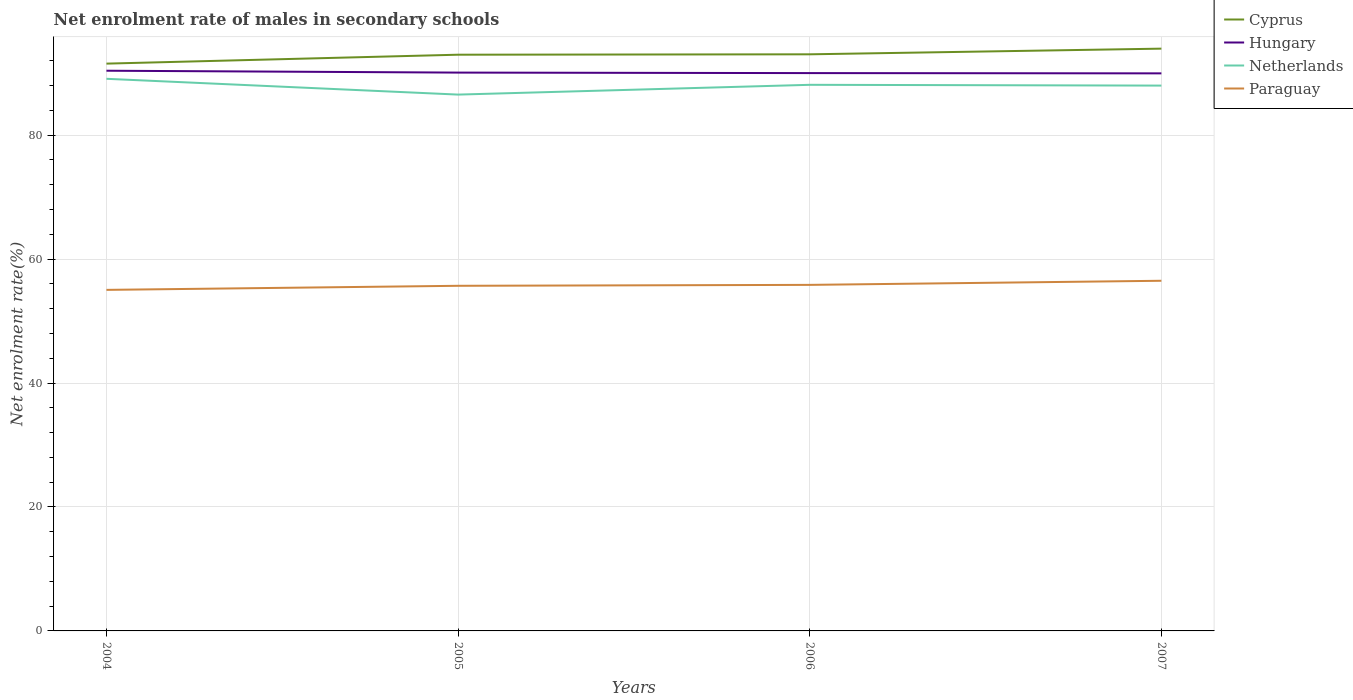How many different coloured lines are there?
Offer a very short reply. 4. Is the number of lines equal to the number of legend labels?
Ensure brevity in your answer.  Yes. Across all years, what is the maximum net enrolment rate of males in secondary schools in Cyprus?
Your answer should be very brief. 91.54. What is the total net enrolment rate of males in secondary schools in Paraguay in the graph?
Give a very brief answer. -0.66. What is the difference between the highest and the second highest net enrolment rate of males in secondary schools in Hungary?
Your answer should be compact. 0.43. Is the net enrolment rate of males in secondary schools in Hungary strictly greater than the net enrolment rate of males in secondary schools in Cyprus over the years?
Ensure brevity in your answer.  Yes. How many lines are there?
Your answer should be compact. 4. How many years are there in the graph?
Your response must be concise. 4. Does the graph contain grids?
Provide a short and direct response. Yes. How many legend labels are there?
Your answer should be compact. 4. What is the title of the graph?
Offer a terse response. Net enrolment rate of males in secondary schools. What is the label or title of the X-axis?
Your response must be concise. Years. What is the label or title of the Y-axis?
Your response must be concise. Net enrolment rate(%). What is the Net enrolment rate(%) in Cyprus in 2004?
Provide a short and direct response. 91.54. What is the Net enrolment rate(%) of Hungary in 2004?
Provide a short and direct response. 90.39. What is the Net enrolment rate(%) of Netherlands in 2004?
Provide a succinct answer. 89.09. What is the Net enrolment rate(%) of Paraguay in 2004?
Ensure brevity in your answer.  55.03. What is the Net enrolment rate(%) in Cyprus in 2005?
Give a very brief answer. 92.97. What is the Net enrolment rate(%) in Hungary in 2005?
Keep it short and to the point. 90.09. What is the Net enrolment rate(%) of Netherlands in 2005?
Your answer should be very brief. 86.54. What is the Net enrolment rate(%) in Paraguay in 2005?
Offer a very short reply. 55.69. What is the Net enrolment rate(%) of Cyprus in 2006?
Your answer should be compact. 93.04. What is the Net enrolment rate(%) of Hungary in 2006?
Provide a succinct answer. 90.01. What is the Net enrolment rate(%) in Netherlands in 2006?
Your answer should be very brief. 88.12. What is the Net enrolment rate(%) of Paraguay in 2006?
Provide a succinct answer. 55.84. What is the Net enrolment rate(%) in Cyprus in 2007?
Your answer should be very brief. 93.95. What is the Net enrolment rate(%) in Hungary in 2007?
Your answer should be compact. 89.97. What is the Net enrolment rate(%) of Netherlands in 2007?
Provide a succinct answer. 87.99. What is the Net enrolment rate(%) in Paraguay in 2007?
Your answer should be very brief. 56.5. Across all years, what is the maximum Net enrolment rate(%) of Cyprus?
Keep it short and to the point. 93.95. Across all years, what is the maximum Net enrolment rate(%) in Hungary?
Offer a very short reply. 90.39. Across all years, what is the maximum Net enrolment rate(%) of Netherlands?
Your response must be concise. 89.09. Across all years, what is the maximum Net enrolment rate(%) of Paraguay?
Provide a short and direct response. 56.5. Across all years, what is the minimum Net enrolment rate(%) of Cyprus?
Your answer should be compact. 91.54. Across all years, what is the minimum Net enrolment rate(%) in Hungary?
Your answer should be compact. 89.97. Across all years, what is the minimum Net enrolment rate(%) of Netherlands?
Your answer should be very brief. 86.54. Across all years, what is the minimum Net enrolment rate(%) of Paraguay?
Give a very brief answer. 55.03. What is the total Net enrolment rate(%) of Cyprus in the graph?
Your answer should be compact. 371.5. What is the total Net enrolment rate(%) in Hungary in the graph?
Provide a short and direct response. 360.46. What is the total Net enrolment rate(%) of Netherlands in the graph?
Make the answer very short. 351.74. What is the total Net enrolment rate(%) of Paraguay in the graph?
Offer a terse response. 223.05. What is the difference between the Net enrolment rate(%) of Cyprus in 2004 and that in 2005?
Your response must be concise. -1.44. What is the difference between the Net enrolment rate(%) in Hungary in 2004 and that in 2005?
Your answer should be compact. 0.3. What is the difference between the Net enrolment rate(%) in Netherlands in 2004 and that in 2005?
Provide a succinct answer. 2.55. What is the difference between the Net enrolment rate(%) of Paraguay in 2004 and that in 2005?
Provide a short and direct response. -0.66. What is the difference between the Net enrolment rate(%) in Cyprus in 2004 and that in 2006?
Provide a short and direct response. -1.5. What is the difference between the Net enrolment rate(%) in Hungary in 2004 and that in 2006?
Provide a succinct answer. 0.38. What is the difference between the Net enrolment rate(%) in Netherlands in 2004 and that in 2006?
Keep it short and to the point. 0.97. What is the difference between the Net enrolment rate(%) in Paraguay in 2004 and that in 2006?
Provide a short and direct response. -0.81. What is the difference between the Net enrolment rate(%) in Cyprus in 2004 and that in 2007?
Ensure brevity in your answer.  -2.42. What is the difference between the Net enrolment rate(%) in Hungary in 2004 and that in 2007?
Provide a short and direct response. 0.43. What is the difference between the Net enrolment rate(%) of Netherlands in 2004 and that in 2007?
Ensure brevity in your answer.  1.09. What is the difference between the Net enrolment rate(%) of Paraguay in 2004 and that in 2007?
Offer a terse response. -1.47. What is the difference between the Net enrolment rate(%) in Cyprus in 2005 and that in 2006?
Provide a short and direct response. -0.07. What is the difference between the Net enrolment rate(%) of Hungary in 2005 and that in 2006?
Your answer should be very brief. 0.08. What is the difference between the Net enrolment rate(%) of Netherlands in 2005 and that in 2006?
Make the answer very short. -1.58. What is the difference between the Net enrolment rate(%) in Paraguay in 2005 and that in 2006?
Ensure brevity in your answer.  -0.15. What is the difference between the Net enrolment rate(%) of Cyprus in 2005 and that in 2007?
Offer a terse response. -0.98. What is the difference between the Net enrolment rate(%) in Hungary in 2005 and that in 2007?
Make the answer very short. 0.12. What is the difference between the Net enrolment rate(%) in Netherlands in 2005 and that in 2007?
Your answer should be compact. -1.45. What is the difference between the Net enrolment rate(%) in Paraguay in 2005 and that in 2007?
Your answer should be compact. -0.81. What is the difference between the Net enrolment rate(%) in Cyprus in 2006 and that in 2007?
Your answer should be compact. -0.91. What is the difference between the Net enrolment rate(%) in Hungary in 2006 and that in 2007?
Provide a short and direct response. 0.04. What is the difference between the Net enrolment rate(%) of Netherlands in 2006 and that in 2007?
Your answer should be compact. 0.13. What is the difference between the Net enrolment rate(%) in Paraguay in 2006 and that in 2007?
Provide a short and direct response. -0.66. What is the difference between the Net enrolment rate(%) of Cyprus in 2004 and the Net enrolment rate(%) of Hungary in 2005?
Your answer should be compact. 1.45. What is the difference between the Net enrolment rate(%) in Cyprus in 2004 and the Net enrolment rate(%) in Netherlands in 2005?
Provide a short and direct response. 5. What is the difference between the Net enrolment rate(%) in Cyprus in 2004 and the Net enrolment rate(%) in Paraguay in 2005?
Ensure brevity in your answer.  35.85. What is the difference between the Net enrolment rate(%) of Hungary in 2004 and the Net enrolment rate(%) of Netherlands in 2005?
Ensure brevity in your answer.  3.85. What is the difference between the Net enrolment rate(%) of Hungary in 2004 and the Net enrolment rate(%) of Paraguay in 2005?
Offer a terse response. 34.7. What is the difference between the Net enrolment rate(%) of Netherlands in 2004 and the Net enrolment rate(%) of Paraguay in 2005?
Provide a succinct answer. 33.4. What is the difference between the Net enrolment rate(%) of Cyprus in 2004 and the Net enrolment rate(%) of Hungary in 2006?
Give a very brief answer. 1.53. What is the difference between the Net enrolment rate(%) in Cyprus in 2004 and the Net enrolment rate(%) in Netherlands in 2006?
Your response must be concise. 3.42. What is the difference between the Net enrolment rate(%) in Cyprus in 2004 and the Net enrolment rate(%) in Paraguay in 2006?
Make the answer very short. 35.7. What is the difference between the Net enrolment rate(%) in Hungary in 2004 and the Net enrolment rate(%) in Netherlands in 2006?
Your answer should be very brief. 2.27. What is the difference between the Net enrolment rate(%) of Hungary in 2004 and the Net enrolment rate(%) of Paraguay in 2006?
Your answer should be compact. 34.56. What is the difference between the Net enrolment rate(%) of Netherlands in 2004 and the Net enrolment rate(%) of Paraguay in 2006?
Ensure brevity in your answer.  33.25. What is the difference between the Net enrolment rate(%) in Cyprus in 2004 and the Net enrolment rate(%) in Hungary in 2007?
Your answer should be very brief. 1.57. What is the difference between the Net enrolment rate(%) of Cyprus in 2004 and the Net enrolment rate(%) of Netherlands in 2007?
Your answer should be compact. 3.54. What is the difference between the Net enrolment rate(%) of Cyprus in 2004 and the Net enrolment rate(%) of Paraguay in 2007?
Your response must be concise. 35.04. What is the difference between the Net enrolment rate(%) of Hungary in 2004 and the Net enrolment rate(%) of Netherlands in 2007?
Offer a terse response. 2.4. What is the difference between the Net enrolment rate(%) of Hungary in 2004 and the Net enrolment rate(%) of Paraguay in 2007?
Ensure brevity in your answer.  33.89. What is the difference between the Net enrolment rate(%) in Netherlands in 2004 and the Net enrolment rate(%) in Paraguay in 2007?
Your answer should be compact. 32.59. What is the difference between the Net enrolment rate(%) of Cyprus in 2005 and the Net enrolment rate(%) of Hungary in 2006?
Provide a short and direct response. 2.97. What is the difference between the Net enrolment rate(%) in Cyprus in 2005 and the Net enrolment rate(%) in Netherlands in 2006?
Your response must be concise. 4.86. What is the difference between the Net enrolment rate(%) in Cyprus in 2005 and the Net enrolment rate(%) in Paraguay in 2006?
Your answer should be compact. 37.14. What is the difference between the Net enrolment rate(%) of Hungary in 2005 and the Net enrolment rate(%) of Netherlands in 2006?
Provide a short and direct response. 1.97. What is the difference between the Net enrolment rate(%) in Hungary in 2005 and the Net enrolment rate(%) in Paraguay in 2006?
Your answer should be compact. 34.25. What is the difference between the Net enrolment rate(%) in Netherlands in 2005 and the Net enrolment rate(%) in Paraguay in 2006?
Your answer should be compact. 30.7. What is the difference between the Net enrolment rate(%) of Cyprus in 2005 and the Net enrolment rate(%) of Hungary in 2007?
Provide a short and direct response. 3.01. What is the difference between the Net enrolment rate(%) of Cyprus in 2005 and the Net enrolment rate(%) of Netherlands in 2007?
Your answer should be compact. 4.98. What is the difference between the Net enrolment rate(%) in Cyprus in 2005 and the Net enrolment rate(%) in Paraguay in 2007?
Your response must be concise. 36.48. What is the difference between the Net enrolment rate(%) in Hungary in 2005 and the Net enrolment rate(%) in Netherlands in 2007?
Offer a very short reply. 2.1. What is the difference between the Net enrolment rate(%) of Hungary in 2005 and the Net enrolment rate(%) of Paraguay in 2007?
Your answer should be very brief. 33.59. What is the difference between the Net enrolment rate(%) in Netherlands in 2005 and the Net enrolment rate(%) in Paraguay in 2007?
Keep it short and to the point. 30.04. What is the difference between the Net enrolment rate(%) of Cyprus in 2006 and the Net enrolment rate(%) of Hungary in 2007?
Your response must be concise. 3.07. What is the difference between the Net enrolment rate(%) in Cyprus in 2006 and the Net enrolment rate(%) in Netherlands in 2007?
Keep it short and to the point. 5.05. What is the difference between the Net enrolment rate(%) of Cyprus in 2006 and the Net enrolment rate(%) of Paraguay in 2007?
Provide a short and direct response. 36.54. What is the difference between the Net enrolment rate(%) of Hungary in 2006 and the Net enrolment rate(%) of Netherlands in 2007?
Make the answer very short. 2.02. What is the difference between the Net enrolment rate(%) of Hungary in 2006 and the Net enrolment rate(%) of Paraguay in 2007?
Offer a terse response. 33.51. What is the difference between the Net enrolment rate(%) of Netherlands in 2006 and the Net enrolment rate(%) of Paraguay in 2007?
Ensure brevity in your answer.  31.62. What is the average Net enrolment rate(%) in Cyprus per year?
Your response must be concise. 92.88. What is the average Net enrolment rate(%) in Hungary per year?
Offer a very short reply. 90.11. What is the average Net enrolment rate(%) in Netherlands per year?
Provide a short and direct response. 87.93. What is the average Net enrolment rate(%) in Paraguay per year?
Your answer should be very brief. 55.76. In the year 2004, what is the difference between the Net enrolment rate(%) of Cyprus and Net enrolment rate(%) of Hungary?
Keep it short and to the point. 1.14. In the year 2004, what is the difference between the Net enrolment rate(%) in Cyprus and Net enrolment rate(%) in Netherlands?
Provide a succinct answer. 2.45. In the year 2004, what is the difference between the Net enrolment rate(%) of Cyprus and Net enrolment rate(%) of Paraguay?
Your answer should be compact. 36.51. In the year 2004, what is the difference between the Net enrolment rate(%) in Hungary and Net enrolment rate(%) in Netherlands?
Make the answer very short. 1.31. In the year 2004, what is the difference between the Net enrolment rate(%) of Hungary and Net enrolment rate(%) of Paraguay?
Your answer should be compact. 35.36. In the year 2004, what is the difference between the Net enrolment rate(%) in Netherlands and Net enrolment rate(%) in Paraguay?
Give a very brief answer. 34.06. In the year 2005, what is the difference between the Net enrolment rate(%) of Cyprus and Net enrolment rate(%) of Hungary?
Offer a very short reply. 2.89. In the year 2005, what is the difference between the Net enrolment rate(%) of Cyprus and Net enrolment rate(%) of Netherlands?
Provide a short and direct response. 6.43. In the year 2005, what is the difference between the Net enrolment rate(%) in Cyprus and Net enrolment rate(%) in Paraguay?
Make the answer very short. 37.29. In the year 2005, what is the difference between the Net enrolment rate(%) in Hungary and Net enrolment rate(%) in Netherlands?
Keep it short and to the point. 3.55. In the year 2005, what is the difference between the Net enrolment rate(%) in Hungary and Net enrolment rate(%) in Paraguay?
Offer a terse response. 34.4. In the year 2005, what is the difference between the Net enrolment rate(%) in Netherlands and Net enrolment rate(%) in Paraguay?
Ensure brevity in your answer.  30.85. In the year 2006, what is the difference between the Net enrolment rate(%) of Cyprus and Net enrolment rate(%) of Hungary?
Keep it short and to the point. 3.03. In the year 2006, what is the difference between the Net enrolment rate(%) in Cyprus and Net enrolment rate(%) in Netherlands?
Keep it short and to the point. 4.92. In the year 2006, what is the difference between the Net enrolment rate(%) in Cyprus and Net enrolment rate(%) in Paraguay?
Provide a short and direct response. 37.2. In the year 2006, what is the difference between the Net enrolment rate(%) in Hungary and Net enrolment rate(%) in Netherlands?
Keep it short and to the point. 1.89. In the year 2006, what is the difference between the Net enrolment rate(%) in Hungary and Net enrolment rate(%) in Paraguay?
Ensure brevity in your answer.  34.17. In the year 2006, what is the difference between the Net enrolment rate(%) in Netherlands and Net enrolment rate(%) in Paraguay?
Your answer should be compact. 32.28. In the year 2007, what is the difference between the Net enrolment rate(%) of Cyprus and Net enrolment rate(%) of Hungary?
Provide a short and direct response. 3.99. In the year 2007, what is the difference between the Net enrolment rate(%) of Cyprus and Net enrolment rate(%) of Netherlands?
Offer a terse response. 5.96. In the year 2007, what is the difference between the Net enrolment rate(%) in Cyprus and Net enrolment rate(%) in Paraguay?
Your answer should be very brief. 37.45. In the year 2007, what is the difference between the Net enrolment rate(%) in Hungary and Net enrolment rate(%) in Netherlands?
Your response must be concise. 1.97. In the year 2007, what is the difference between the Net enrolment rate(%) in Hungary and Net enrolment rate(%) in Paraguay?
Your answer should be compact. 33.47. In the year 2007, what is the difference between the Net enrolment rate(%) in Netherlands and Net enrolment rate(%) in Paraguay?
Ensure brevity in your answer.  31.49. What is the ratio of the Net enrolment rate(%) of Cyprus in 2004 to that in 2005?
Provide a short and direct response. 0.98. What is the ratio of the Net enrolment rate(%) of Hungary in 2004 to that in 2005?
Make the answer very short. 1. What is the ratio of the Net enrolment rate(%) of Netherlands in 2004 to that in 2005?
Make the answer very short. 1.03. What is the ratio of the Net enrolment rate(%) in Cyprus in 2004 to that in 2006?
Your answer should be compact. 0.98. What is the ratio of the Net enrolment rate(%) in Hungary in 2004 to that in 2006?
Your answer should be compact. 1. What is the ratio of the Net enrolment rate(%) of Paraguay in 2004 to that in 2006?
Your response must be concise. 0.99. What is the ratio of the Net enrolment rate(%) in Cyprus in 2004 to that in 2007?
Ensure brevity in your answer.  0.97. What is the ratio of the Net enrolment rate(%) of Hungary in 2004 to that in 2007?
Your answer should be compact. 1. What is the ratio of the Net enrolment rate(%) in Netherlands in 2004 to that in 2007?
Offer a very short reply. 1.01. What is the ratio of the Net enrolment rate(%) in Cyprus in 2005 to that in 2006?
Make the answer very short. 1. What is the ratio of the Net enrolment rate(%) of Netherlands in 2005 to that in 2006?
Your answer should be very brief. 0.98. What is the ratio of the Net enrolment rate(%) in Netherlands in 2005 to that in 2007?
Offer a very short reply. 0.98. What is the ratio of the Net enrolment rate(%) in Paraguay in 2005 to that in 2007?
Offer a very short reply. 0.99. What is the ratio of the Net enrolment rate(%) of Cyprus in 2006 to that in 2007?
Offer a terse response. 0.99. What is the ratio of the Net enrolment rate(%) in Netherlands in 2006 to that in 2007?
Make the answer very short. 1. What is the ratio of the Net enrolment rate(%) of Paraguay in 2006 to that in 2007?
Your response must be concise. 0.99. What is the difference between the highest and the second highest Net enrolment rate(%) in Cyprus?
Ensure brevity in your answer.  0.91. What is the difference between the highest and the second highest Net enrolment rate(%) of Hungary?
Offer a very short reply. 0.3. What is the difference between the highest and the second highest Net enrolment rate(%) of Netherlands?
Ensure brevity in your answer.  0.97. What is the difference between the highest and the second highest Net enrolment rate(%) of Paraguay?
Ensure brevity in your answer.  0.66. What is the difference between the highest and the lowest Net enrolment rate(%) of Cyprus?
Give a very brief answer. 2.42. What is the difference between the highest and the lowest Net enrolment rate(%) of Hungary?
Give a very brief answer. 0.43. What is the difference between the highest and the lowest Net enrolment rate(%) in Netherlands?
Make the answer very short. 2.55. What is the difference between the highest and the lowest Net enrolment rate(%) in Paraguay?
Give a very brief answer. 1.47. 